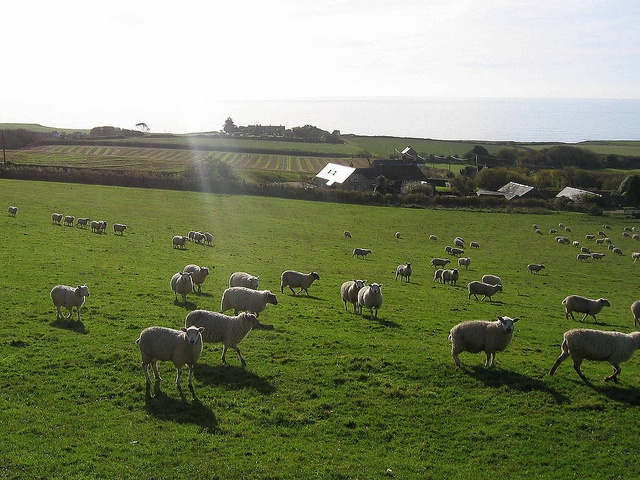Describe the objects in this image and their specific colors. I can see sheep in white, darkgreen, black, gray, and olive tones, sheep in white, black, darkgreen, and gray tones, sheep in white, black, gray, darkgreen, and darkgray tones, sheep in white, black, gray, and darkgreen tones, and sheep in white, black, gray, and darkgray tones in this image. 